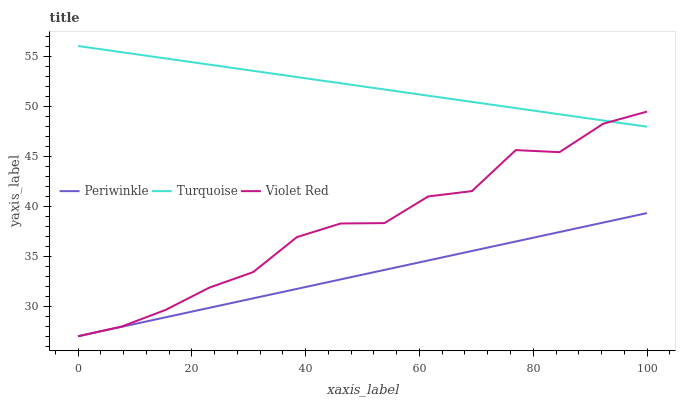Does Periwinkle have the minimum area under the curve?
Answer yes or no. Yes. Does Turquoise have the maximum area under the curve?
Answer yes or no. Yes. Does Violet Red have the minimum area under the curve?
Answer yes or no. No. Does Violet Red have the maximum area under the curve?
Answer yes or no. No. Is Periwinkle the smoothest?
Answer yes or no. Yes. Is Violet Red the roughest?
Answer yes or no. Yes. Is Violet Red the smoothest?
Answer yes or no. No. Is Periwinkle the roughest?
Answer yes or no. No. Does Periwinkle have the lowest value?
Answer yes or no. Yes. Does Turquoise have the highest value?
Answer yes or no. Yes. Does Violet Red have the highest value?
Answer yes or no. No. Is Periwinkle less than Turquoise?
Answer yes or no. Yes. Is Turquoise greater than Periwinkle?
Answer yes or no. Yes. Does Violet Red intersect Turquoise?
Answer yes or no. Yes. Is Violet Red less than Turquoise?
Answer yes or no. No. Is Violet Red greater than Turquoise?
Answer yes or no. No. Does Periwinkle intersect Turquoise?
Answer yes or no. No. 